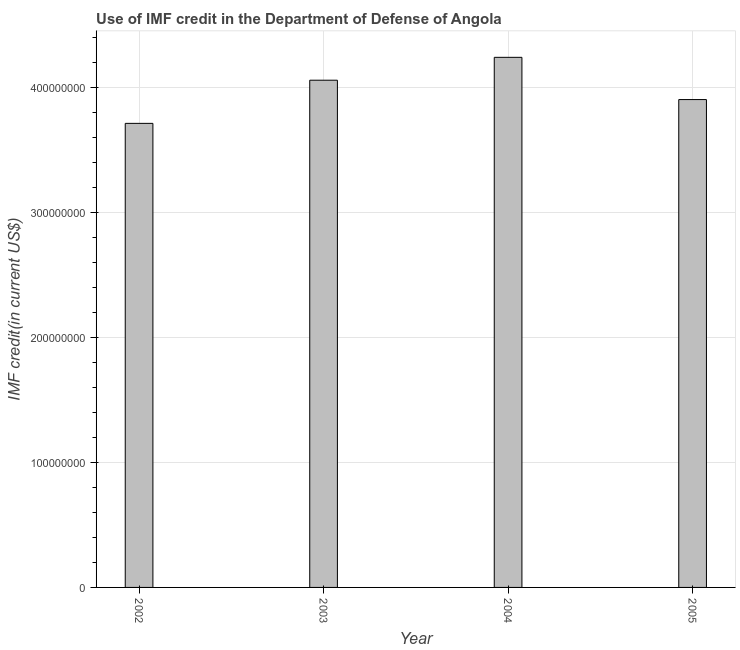Does the graph contain any zero values?
Your answer should be very brief. No. Does the graph contain grids?
Give a very brief answer. Yes. What is the title of the graph?
Offer a terse response. Use of IMF credit in the Department of Defense of Angola. What is the label or title of the X-axis?
Your answer should be compact. Year. What is the label or title of the Y-axis?
Your response must be concise. IMF credit(in current US$). What is the use of imf credit in dod in 2002?
Your answer should be compact. 3.71e+08. Across all years, what is the maximum use of imf credit in dod?
Give a very brief answer. 4.24e+08. Across all years, what is the minimum use of imf credit in dod?
Keep it short and to the point. 3.71e+08. What is the sum of the use of imf credit in dod?
Provide a succinct answer. 1.59e+09. What is the difference between the use of imf credit in dod in 2002 and 2005?
Offer a terse response. -1.90e+07. What is the average use of imf credit in dod per year?
Provide a short and direct response. 3.98e+08. What is the median use of imf credit in dod?
Give a very brief answer. 3.98e+08. Do a majority of the years between 2003 and 2004 (inclusive) have use of imf credit in dod greater than 360000000 US$?
Your answer should be compact. Yes. Is the use of imf credit in dod in 2002 less than that in 2003?
Provide a short and direct response. Yes. Is the difference between the use of imf credit in dod in 2002 and 2004 greater than the difference between any two years?
Make the answer very short. Yes. What is the difference between the highest and the second highest use of imf credit in dod?
Your response must be concise. 1.83e+07. Is the sum of the use of imf credit in dod in 2003 and 2005 greater than the maximum use of imf credit in dod across all years?
Offer a terse response. Yes. What is the difference between the highest and the lowest use of imf credit in dod?
Keep it short and to the point. 5.28e+07. In how many years, is the use of imf credit in dod greater than the average use of imf credit in dod taken over all years?
Your answer should be compact. 2. Are the values on the major ticks of Y-axis written in scientific E-notation?
Give a very brief answer. No. What is the IMF credit(in current US$) in 2002?
Offer a very short reply. 3.71e+08. What is the IMF credit(in current US$) of 2003?
Offer a very short reply. 4.06e+08. What is the IMF credit(in current US$) in 2004?
Offer a terse response. 4.24e+08. What is the IMF credit(in current US$) in 2005?
Ensure brevity in your answer.  3.90e+08. What is the difference between the IMF credit(in current US$) in 2002 and 2003?
Give a very brief answer. -3.45e+07. What is the difference between the IMF credit(in current US$) in 2002 and 2004?
Keep it short and to the point. -5.28e+07. What is the difference between the IMF credit(in current US$) in 2002 and 2005?
Give a very brief answer. -1.90e+07. What is the difference between the IMF credit(in current US$) in 2003 and 2004?
Give a very brief answer. -1.83e+07. What is the difference between the IMF credit(in current US$) in 2003 and 2005?
Give a very brief answer. 1.55e+07. What is the difference between the IMF credit(in current US$) in 2004 and 2005?
Ensure brevity in your answer.  3.38e+07. What is the ratio of the IMF credit(in current US$) in 2002 to that in 2003?
Provide a succinct answer. 0.92. What is the ratio of the IMF credit(in current US$) in 2002 to that in 2005?
Keep it short and to the point. 0.95. What is the ratio of the IMF credit(in current US$) in 2003 to that in 2004?
Ensure brevity in your answer.  0.96. What is the ratio of the IMF credit(in current US$) in 2004 to that in 2005?
Provide a short and direct response. 1.09. 